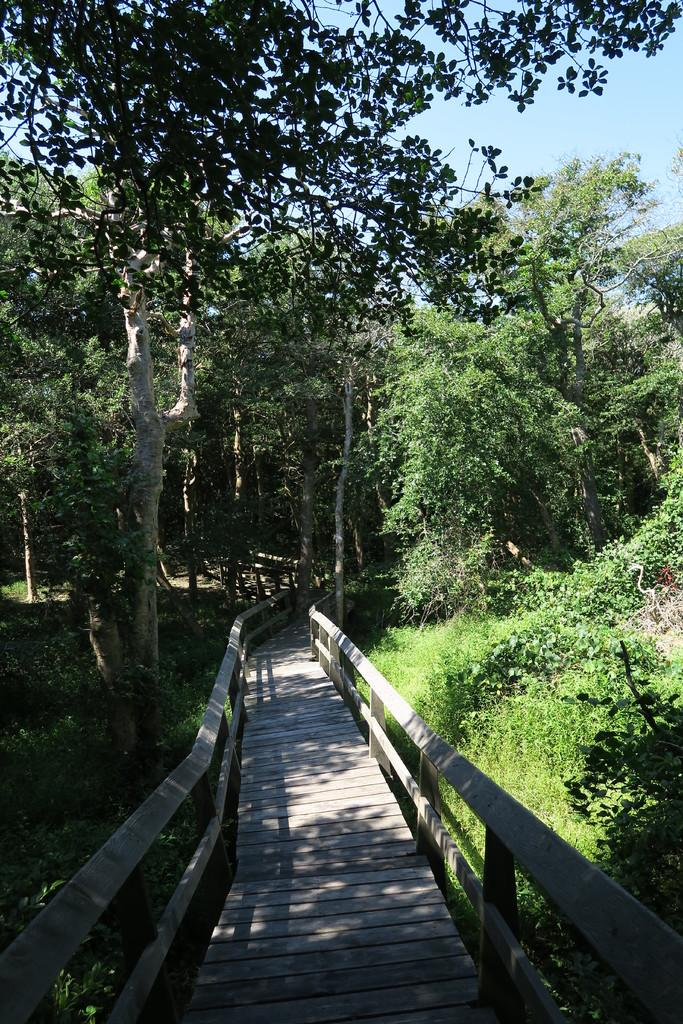What type of path is in the middle of the image? There is a wooden path in the middle of the image. What feature is present beside the wooden path? Railings are present beside the wooden path. What type of vegetation can be seen in the image? Trees and plants are visible in the image. Can you see a farmer using a quill to write on a foot in the image? No, there is no farmer, quill, or foot present in the image. 